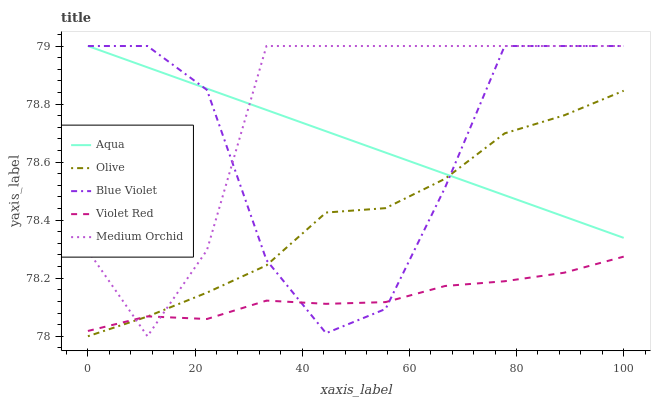Does Violet Red have the minimum area under the curve?
Answer yes or no. Yes. Does Medium Orchid have the maximum area under the curve?
Answer yes or no. Yes. Does Medium Orchid have the minimum area under the curve?
Answer yes or no. No. Does Violet Red have the maximum area under the curve?
Answer yes or no. No. Is Aqua the smoothest?
Answer yes or no. Yes. Is Blue Violet the roughest?
Answer yes or no. Yes. Is Violet Red the smoothest?
Answer yes or no. No. Is Violet Red the roughest?
Answer yes or no. No. Does Olive have the lowest value?
Answer yes or no. Yes. Does Violet Red have the lowest value?
Answer yes or no. No. Does Blue Violet have the highest value?
Answer yes or no. Yes. Does Violet Red have the highest value?
Answer yes or no. No. Is Violet Red less than Aqua?
Answer yes or no. Yes. Is Aqua greater than Violet Red?
Answer yes or no. Yes. Does Medium Orchid intersect Violet Red?
Answer yes or no. Yes. Is Medium Orchid less than Violet Red?
Answer yes or no. No. Is Medium Orchid greater than Violet Red?
Answer yes or no. No. Does Violet Red intersect Aqua?
Answer yes or no. No. 